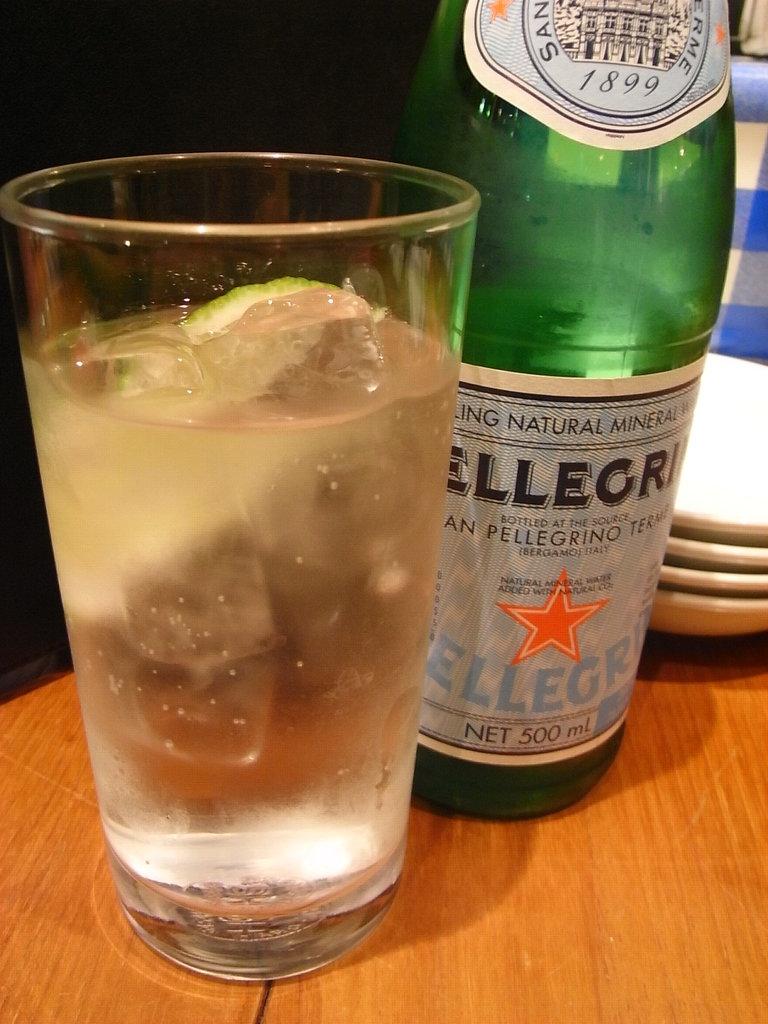What is the volume of this bottle?
Make the answer very short. 500 ml. 